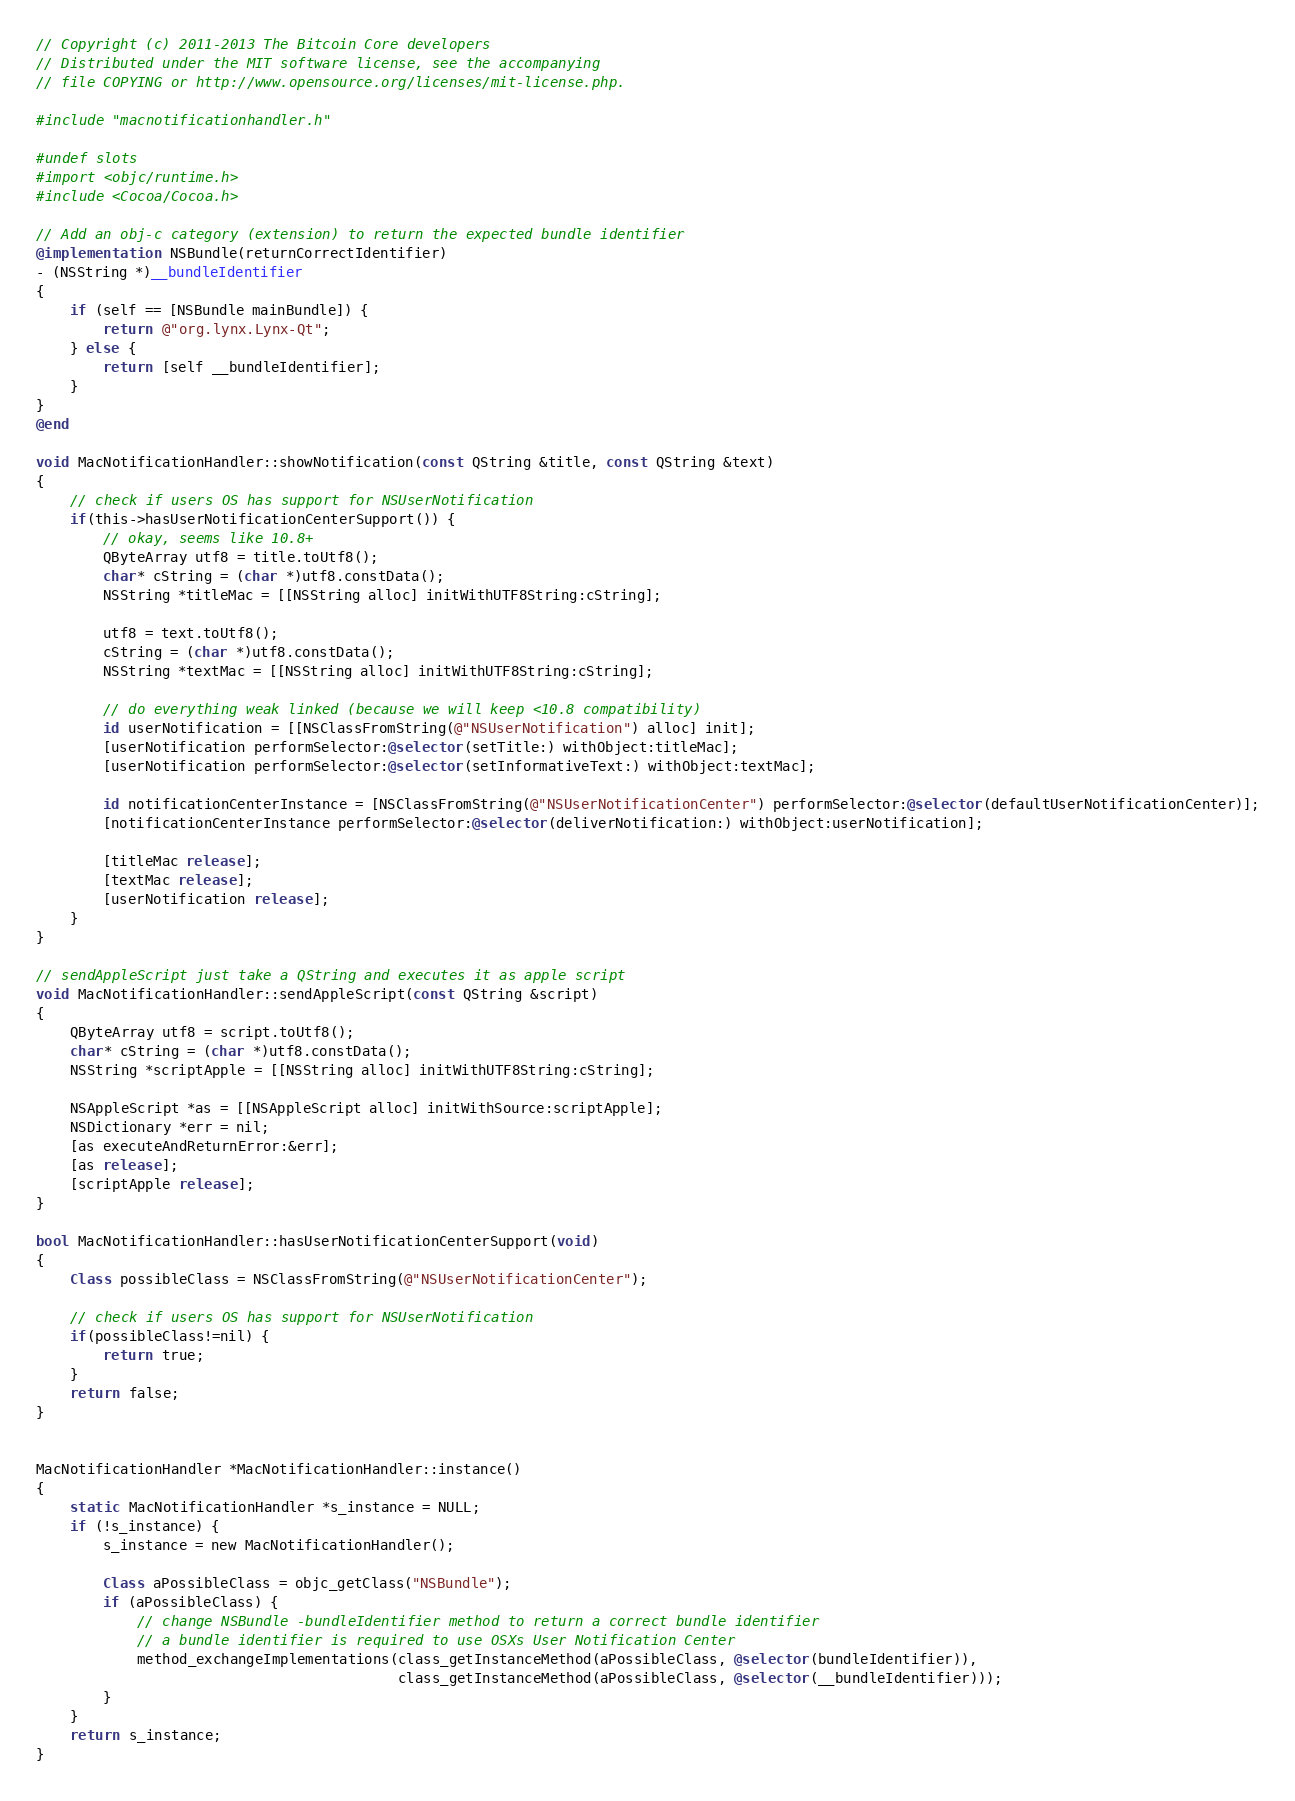Convert code to text. <code><loc_0><loc_0><loc_500><loc_500><_ObjectiveC_>// Copyright (c) 2011-2013 The Bitcoin Core developers
// Distributed under the MIT software license, see the accompanying
// file COPYING or http://www.opensource.org/licenses/mit-license.php.

#include "macnotificationhandler.h"

#undef slots
#import <objc/runtime.h>
#include <Cocoa/Cocoa.h>

// Add an obj-c category (extension) to return the expected bundle identifier
@implementation NSBundle(returnCorrectIdentifier)
- (NSString *)__bundleIdentifier
{
    if (self == [NSBundle mainBundle]) {
        return @"org.lynx.Lynx-Qt";
    } else {
        return [self __bundleIdentifier];
    }
}
@end

void MacNotificationHandler::showNotification(const QString &title, const QString &text)
{
    // check if users OS has support for NSUserNotification
    if(this->hasUserNotificationCenterSupport()) {
        // okay, seems like 10.8+
        QByteArray utf8 = title.toUtf8();
        char* cString = (char *)utf8.constData();
        NSString *titleMac = [[NSString alloc] initWithUTF8String:cString];

        utf8 = text.toUtf8();
        cString = (char *)utf8.constData();
        NSString *textMac = [[NSString alloc] initWithUTF8String:cString];

        // do everything weak linked (because we will keep <10.8 compatibility)
        id userNotification = [[NSClassFromString(@"NSUserNotification") alloc] init];
        [userNotification performSelector:@selector(setTitle:) withObject:titleMac];
        [userNotification performSelector:@selector(setInformativeText:) withObject:textMac];

        id notificationCenterInstance = [NSClassFromString(@"NSUserNotificationCenter") performSelector:@selector(defaultUserNotificationCenter)];
        [notificationCenterInstance performSelector:@selector(deliverNotification:) withObject:userNotification];

        [titleMac release];
        [textMac release];
        [userNotification release];
    }
}

// sendAppleScript just take a QString and executes it as apple script
void MacNotificationHandler::sendAppleScript(const QString &script)
{
    QByteArray utf8 = script.toUtf8();
    char* cString = (char *)utf8.constData();
    NSString *scriptApple = [[NSString alloc] initWithUTF8String:cString];

    NSAppleScript *as = [[NSAppleScript alloc] initWithSource:scriptApple];
    NSDictionary *err = nil;
    [as executeAndReturnError:&err];
    [as release];
    [scriptApple release];
}

bool MacNotificationHandler::hasUserNotificationCenterSupport(void)
{
    Class possibleClass = NSClassFromString(@"NSUserNotificationCenter");

    // check if users OS has support for NSUserNotification
    if(possibleClass!=nil) {
        return true;
    }
    return false;
}


MacNotificationHandler *MacNotificationHandler::instance()
{
    static MacNotificationHandler *s_instance = NULL;
    if (!s_instance) {
        s_instance = new MacNotificationHandler();
        
        Class aPossibleClass = objc_getClass("NSBundle");
        if (aPossibleClass) {
            // change NSBundle -bundleIdentifier method to return a correct bundle identifier
            // a bundle identifier is required to use OSXs User Notification Center
            method_exchangeImplementations(class_getInstanceMethod(aPossibleClass, @selector(bundleIdentifier)),
                                           class_getInstanceMethod(aPossibleClass, @selector(__bundleIdentifier)));
        }
    }
    return s_instance;
}
</code> 